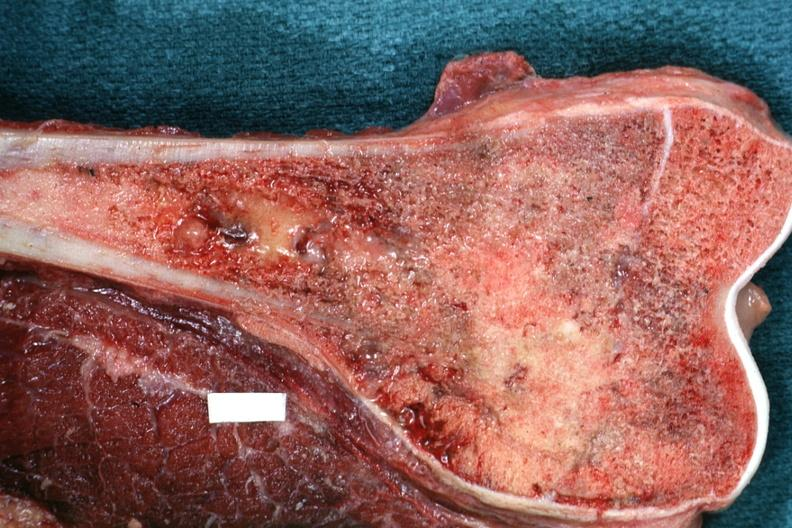how is sectioned femur lesion distal end example?
Answer the question using a single word or phrase. Excellent 